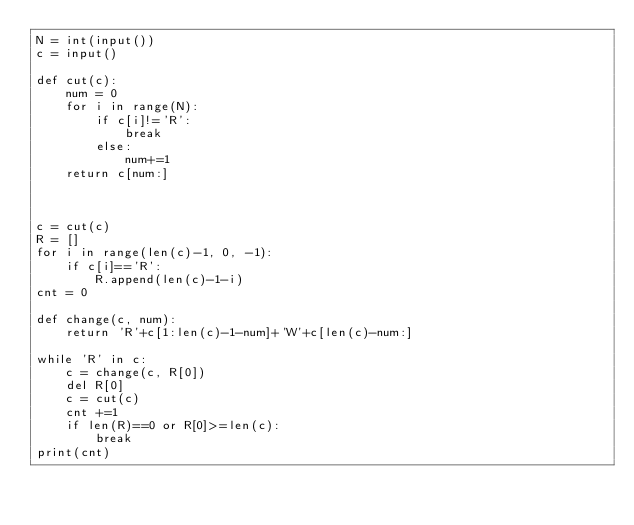<code> <loc_0><loc_0><loc_500><loc_500><_Python_>N = int(input())
c = input()

def cut(c):
    num = 0
    for i in range(N):
        if c[i]!='R':
            break
        else:
            num+=1
    return c[num:]


    
c = cut(c)
R = []
for i in range(len(c)-1, 0, -1):
    if c[i]=='R':
        R.append(len(c)-1-i)
cnt = 0

def change(c, num):
    return 'R'+c[1:len(c)-1-num]+'W'+c[len(c)-num:]
        
while 'R' in c:
    c = change(c, R[0])
    del R[0]
    c = cut(c)
    cnt +=1
    if len(R)==0 or R[0]>=len(c):
        break
print(cnt)</code> 